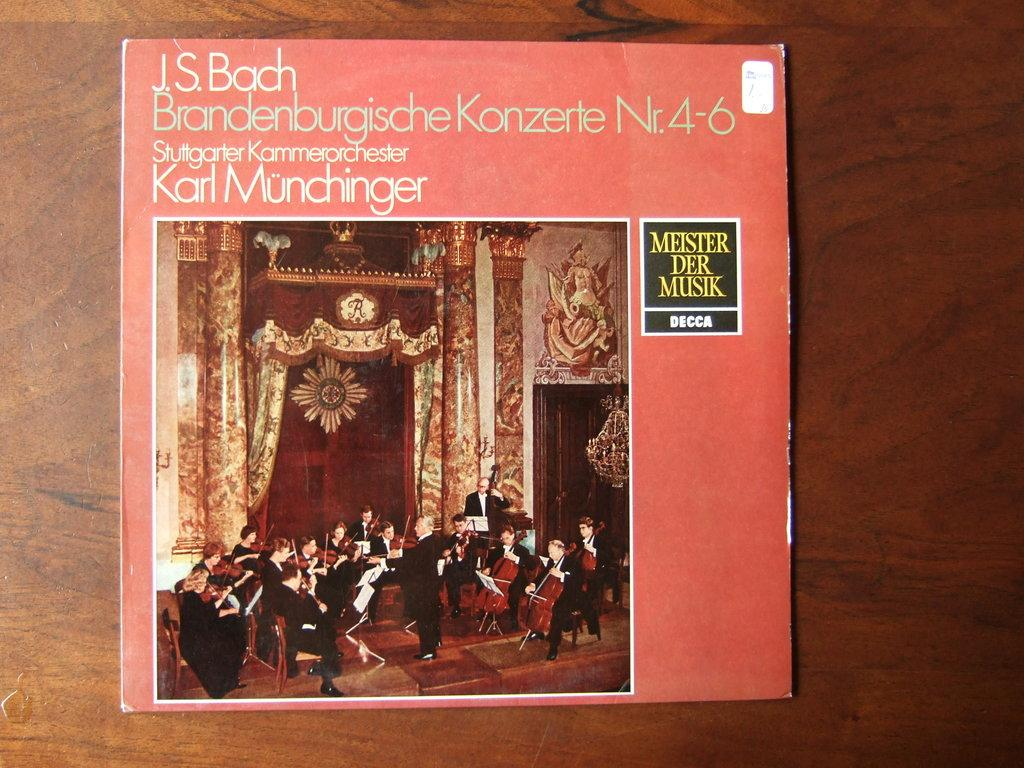<image>
Create a compact narrative representing the image presented. A pink vinyl record of J.S. Bach music with an orchestra on it. 